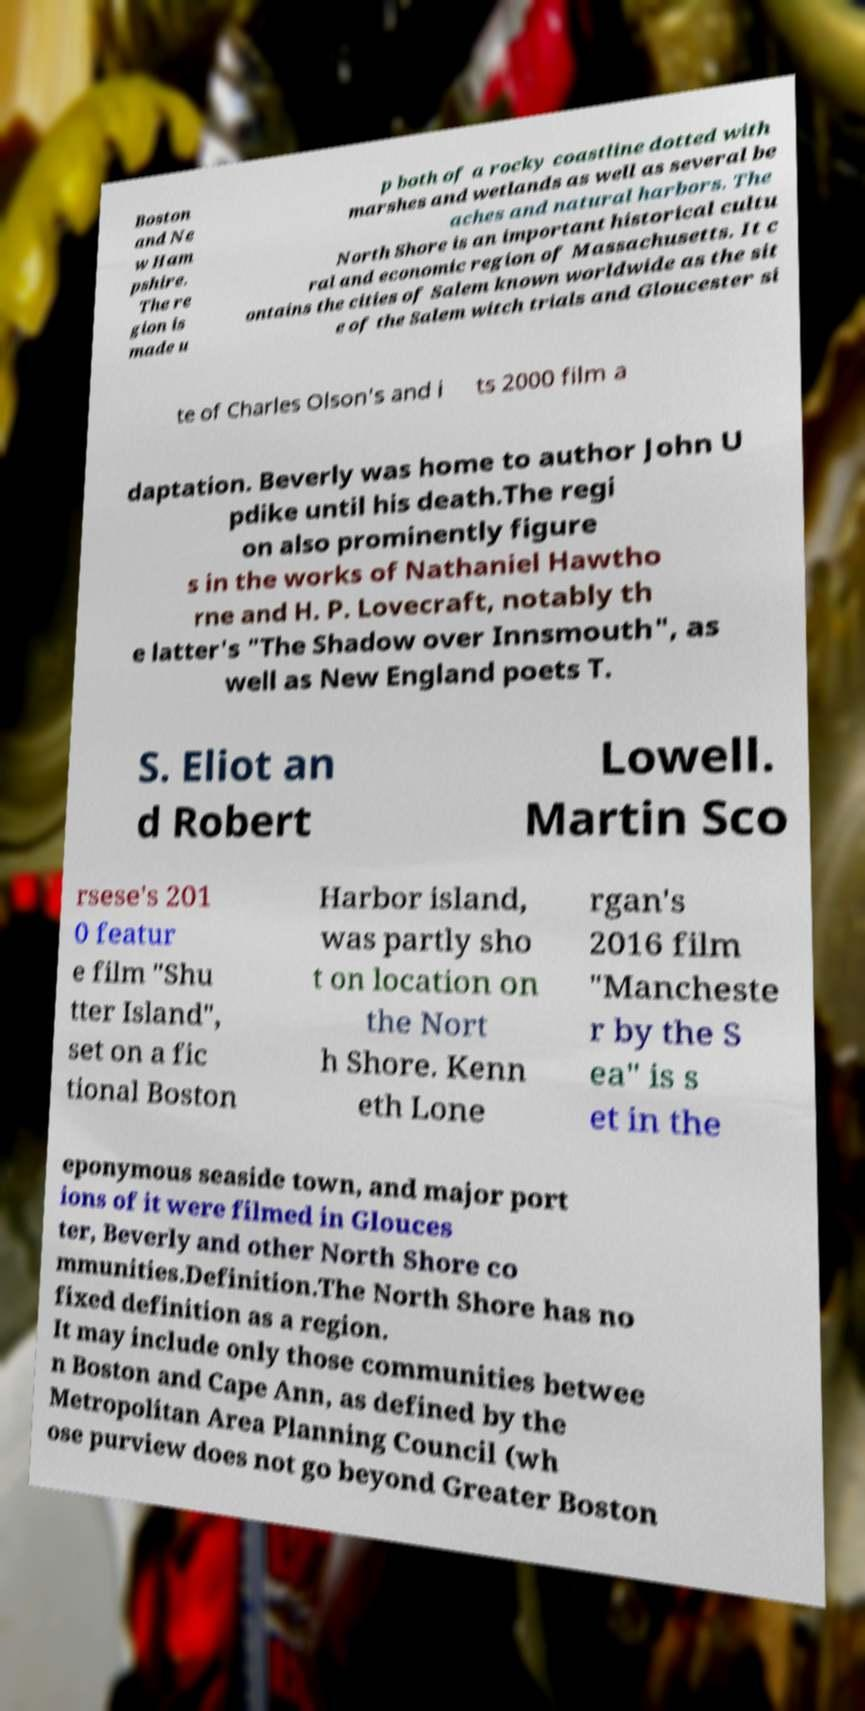Could you extract and type out the text from this image? Boston and Ne w Ham pshire. The re gion is made u p both of a rocky coastline dotted with marshes and wetlands as well as several be aches and natural harbors. The North Shore is an important historical cultu ral and economic region of Massachusetts. It c ontains the cities of Salem known worldwide as the sit e of the Salem witch trials and Gloucester si te of Charles Olson's and i ts 2000 film a daptation. Beverly was home to author John U pdike until his death.The regi on also prominently figure s in the works of Nathaniel Hawtho rne and H. P. Lovecraft, notably th e latter's "The Shadow over Innsmouth", as well as New England poets T. S. Eliot an d Robert Lowell. Martin Sco rsese's 201 0 featur e film "Shu tter Island", set on a fic tional Boston Harbor island, was partly sho t on location on the Nort h Shore. Kenn eth Lone rgan's 2016 film "Mancheste r by the S ea" is s et in the eponymous seaside town, and major port ions of it were filmed in Glouces ter, Beverly and other North Shore co mmunities.Definition.The North Shore has no fixed definition as a region. It may include only those communities betwee n Boston and Cape Ann, as defined by the Metropolitan Area Planning Council (wh ose purview does not go beyond Greater Boston 